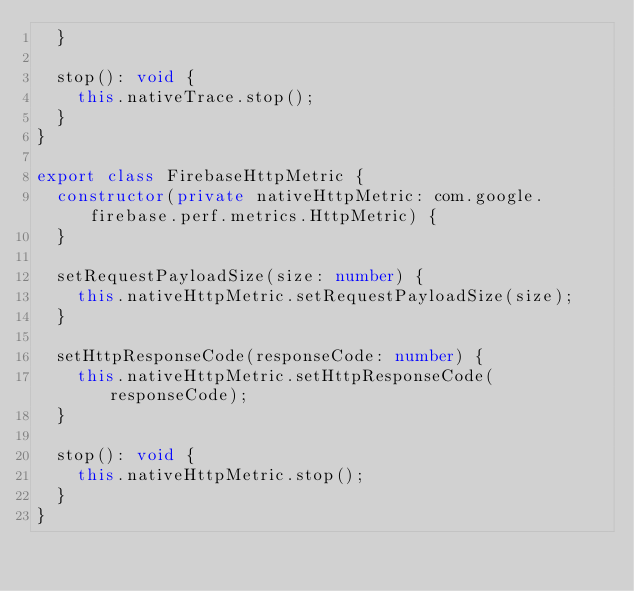<code> <loc_0><loc_0><loc_500><loc_500><_TypeScript_>  }

  stop(): void {
    this.nativeTrace.stop();
  }
}

export class FirebaseHttpMetric {
  constructor(private nativeHttpMetric: com.google.firebase.perf.metrics.HttpMetric) {
  }

  setRequestPayloadSize(size: number) {
    this.nativeHttpMetric.setRequestPayloadSize(size);
  }

  setHttpResponseCode(responseCode: number) {
    this.nativeHttpMetric.setHttpResponseCode(responseCode);
  }

  stop(): void {
    this.nativeHttpMetric.stop();
  }
}</code> 